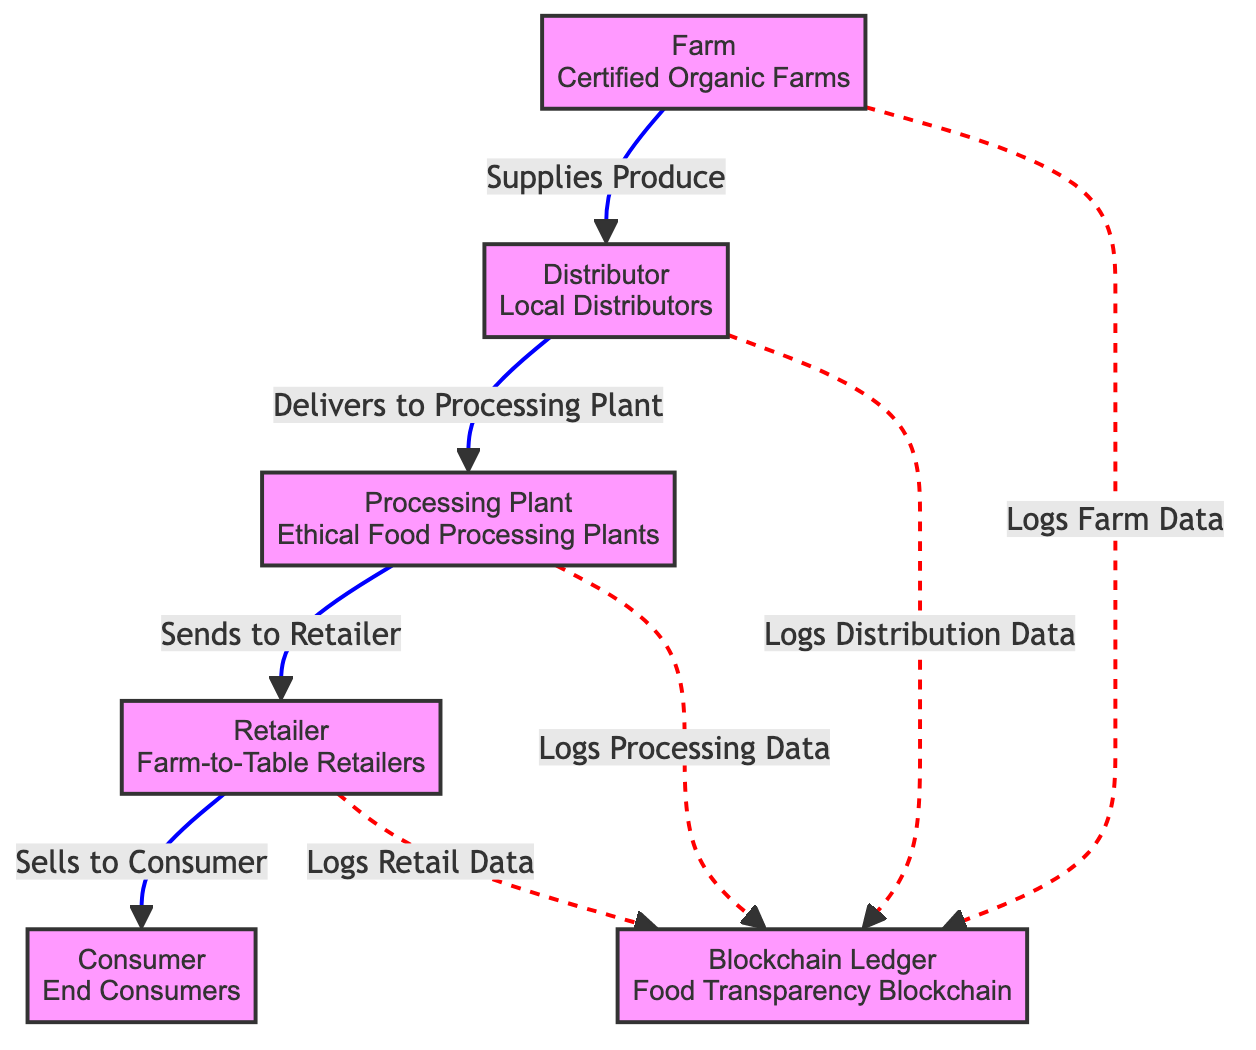What is the first node in the food chain? The first node is labeled "Farm" and specifically refers to "Certified Organic Farms." It is the starting point of the food chain, indicating the source of produce.
Answer: Farm How many nodes are in this food chain diagram? The diagram contains six nodes: Farm, Distributor, Processing Plant, Retailer, Consumer, and Blockchain Ledger, representing different stages in the food chain.
Answer: 6 Which node receives produce from the farm? The "Distributor" node receives produce from the "Farm" node, as indicated by the direct connecting line.
Answer: Distributor What type of data does the processing plant log? The "Processing Plant" specifically logs "Processing Data" into the "Blockchain Ledger," which is indicated by a dashed line connecting the two nodes.
Answer: Processing Data How does the retailer acquire products? The "Retailer" acquires products from the "Processing Plant," as shown by the arrow indicating the flow of products from the Processing Plant to the Retailer.
Answer: Processing Plant Why is the blockchain important in this food chain? The blockchain serves as a "Food Transparency Blockchain," allowing for the logging of important data at each stage of the food chain, ensuring ethical sourcing practices. This illustrates its function in providing transparency and trust.
Answer: Food Transparency Blockchain What is the relationship between the consumer and the retailer? The "Consumer" node is directly sold products by the "Retailer," as indicated by the connecting line pointing from the Retailer to the Consumer node.
Answer: Sells Which node is responsible for ethical food processing? The node labeled "Processing Plant" refers to "Ethical Food Processing Plants," meaning it specializes in processing food ethically.
Answer: Ethical Food Processing Plants What type of connection is used for logging data? The diagram uses a dashed line (indicated in red) to represent the connections where different entities log data into the "Blockchain Ledger," contrasting with solid connections that depict the flow of goods.
Answer: Dashed line 